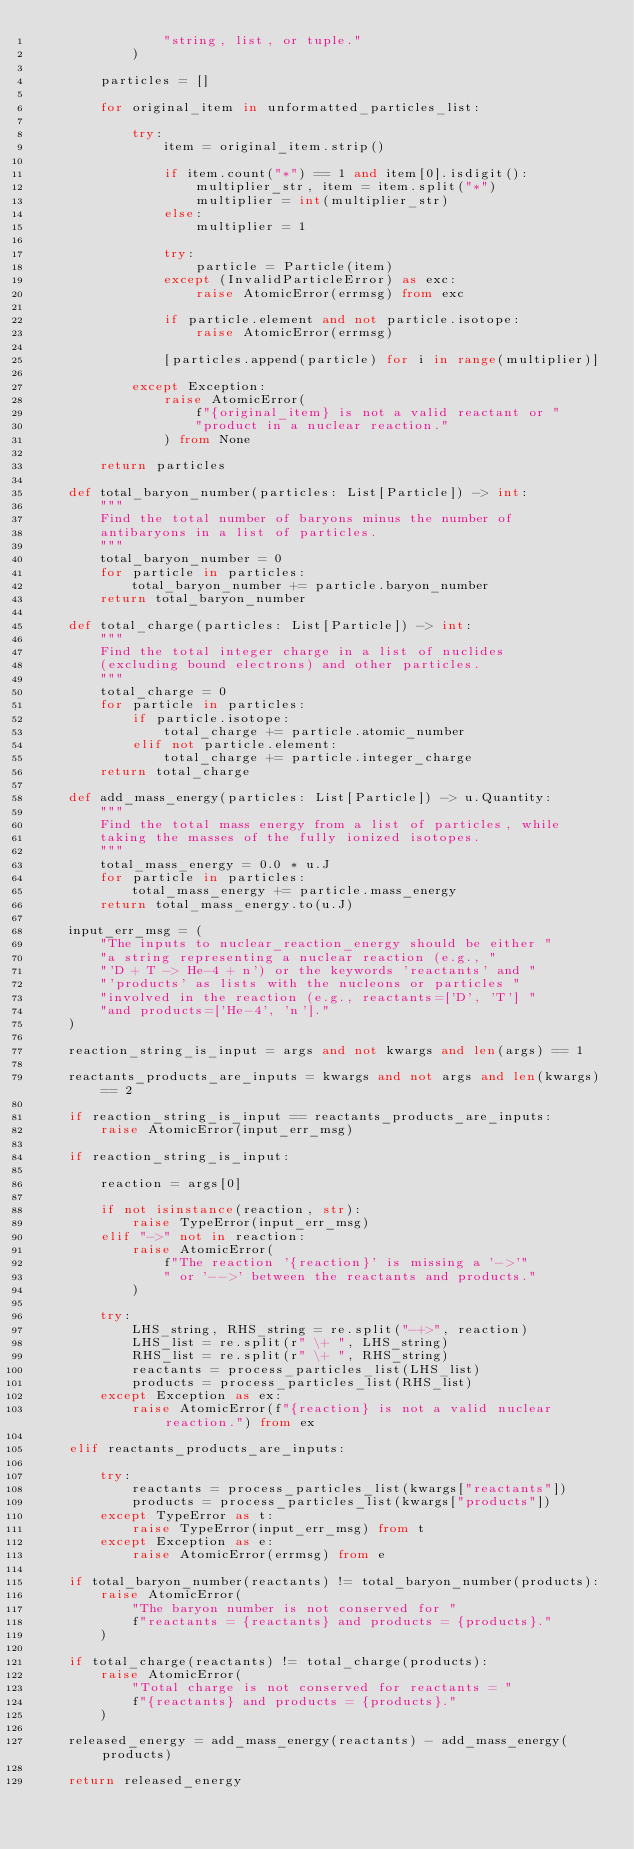Convert code to text. <code><loc_0><loc_0><loc_500><loc_500><_Python_>                "string, list, or tuple."
            )

        particles = []

        for original_item in unformatted_particles_list:

            try:
                item = original_item.strip()

                if item.count("*") == 1 and item[0].isdigit():
                    multiplier_str, item = item.split("*")
                    multiplier = int(multiplier_str)
                else:
                    multiplier = 1

                try:
                    particle = Particle(item)
                except (InvalidParticleError) as exc:
                    raise AtomicError(errmsg) from exc

                if particle.element and not particle.isotope:
                    raise AtomicError(errmsg)

                [particles.append(particle) for i in range(multiplier)]

            except Exception:
                raise AtomicError(
                    f"{original_item} is not a valid reactant or "
                    "product in a nuclear reaction."
                ) from None

        return particles

    def total_baryon_number(particles: List[Particle]) -> int:
        """
        Find the total number of baryons minus the number of
        antibaryons in a list of particles.
        """
        total_baryon_number = 0
        for particle in particles:
            total_baryon_number += particle.baryon_number
        return total_baryon_number

    def total_charge(particles: List[Particle]) -> int:
        """
        Find the total integer charge in a list of nuclides
        (excluding bound electrons) and other particles.
        """
        total_charge = 0
        for particle in particles:
            if particle.isotope:
                total_charge += particle.atomic_number
            elif not particle.element:
                total_charge += particle.integer_charge
        return total_charge

    def add_mass_energy(particles: List[Particle]) -> u.Quantity:
        """
        Find the total mass energy from a list of particles, while
        taking the masses of the fully ionized isotopes.
        """
        total_mass_energy = 0.0 * u.J
        for particle in particles:
            total_mass_energy += particle.mass_energy
        return total_mass_energy.to(u.J)

    input_err_msg = (
        "The inputs to nuclear_reaction_energy should be either "
        "a string representing a nuclear reaction (e.g., "
        "'D + T -> He-4 + n') or the keywords 'reactants' and "
        "'products' as lists with the nucleons or particles "
        "involved in the reaction (e.g., reactants=['D', 'T'] "
        "and products=['He-4', 'n']."
    )

    reaction_string_is_input = args and not kwargs and len(args) == 1

    reactants_products_are_inputs = kwargs and not args and len(kwargs) == 2

    if reaction_string_is_input == reactants_products_are_inputs:
        raise AtomicError(input_err_msg)

    if reaction_string_is_input:

        reaction = args[0]

        if not isinstance(reaction, str):
            raise TypeError(input_err_msg)
        elif "->" not in reaction:
            raise AtomicError(
                f"The reaction '{reaction}' is missing a '->'"
                " or '-->' between the reactants and products."
            )

        try:
            LHS_string, RHS_string = re.split("-+>", reaction)
            LHS_list = re.split(r" \+ ", LHS_string)
            RHS_list = re.split(r" \+ ", RHS_string)
            reactants = process_particles_list(LHS_list)
            products = process_particles_list(RHS_list)
        except Exception as ex:
            raise AtomicError(f"{reaction} is not a valid nuclear reaction.") from ex

    elif reactants_products_are_inputs:

        try:
            reactants = process_particles_list(kwargs["reactants"])
            products = process_particles_list(kwargs["products"])
        except TypeError as t:
            raise TypeError(input_err_msg) from t
        except Exception as e:
            raise AtomicError(errmsg) from e

    if total_baryon_number(reactants) != total_baryon_number(products):
        raise AtomicError(
            "The baryon number is not conserved for "
            f"reactants = {reactants} and products = {products}."
        )

    if total_charge(reactants) != total_charge(products):
        raise AtomicError(
            "Total charge is not conserved for reactants = "
            f"{reactants} and products = {products}."
        )

    released_energy = add_mass_energy(reactants) - add_mass_energy(products)

    return released_energy
</code> 